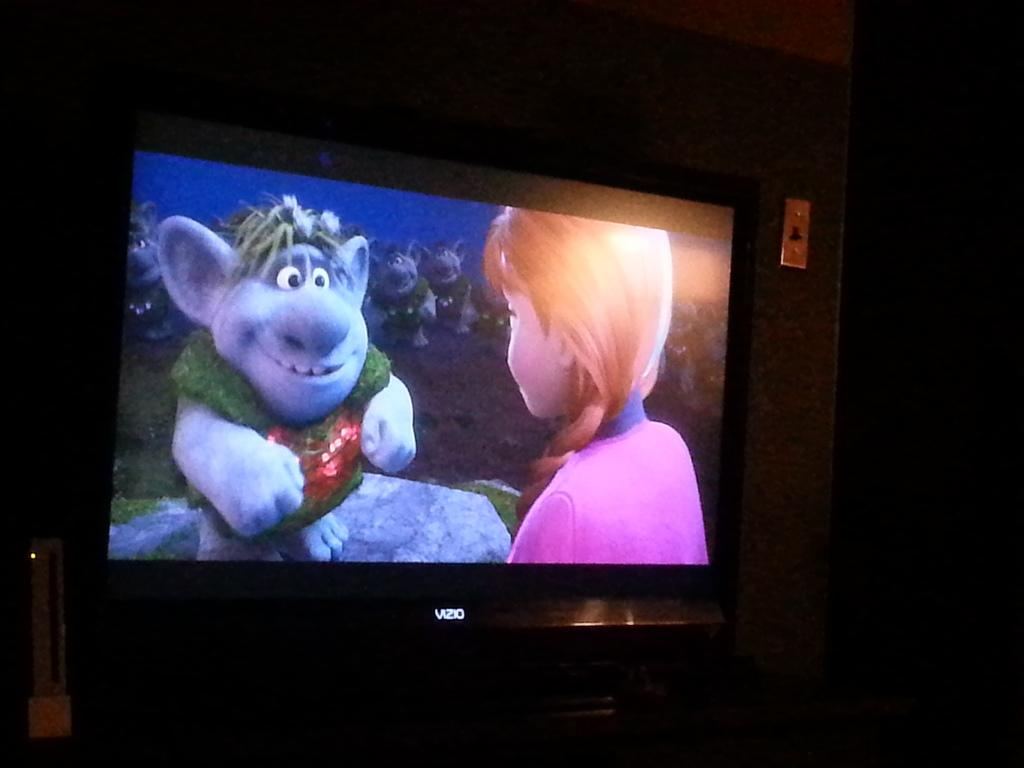<image>
Render a clear and concise summary of the photo. VIZIO tv playing the movie Frozen in color 